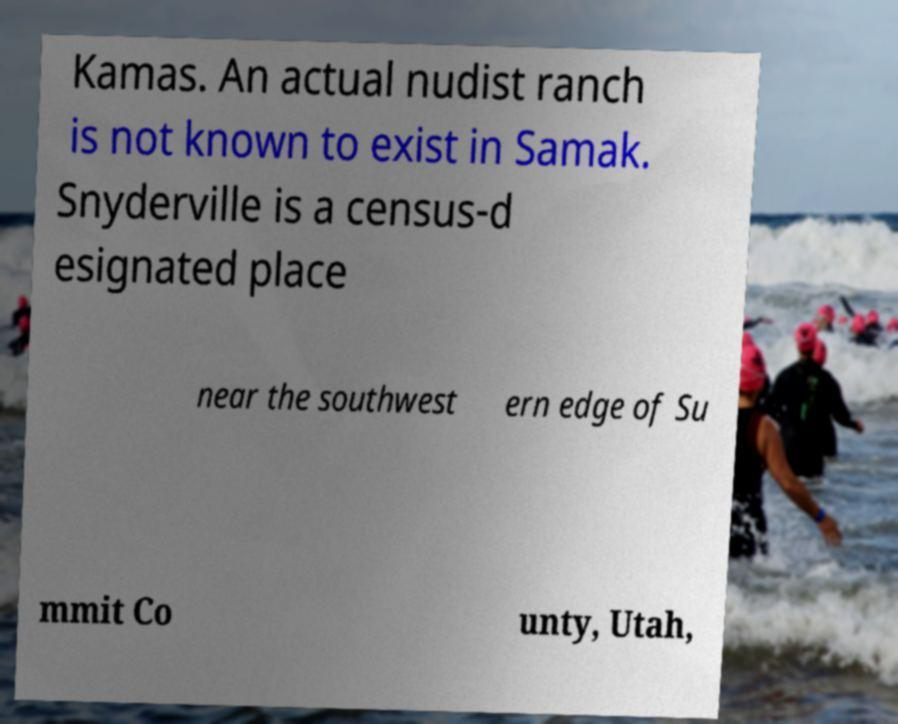There's text embedded in this image that I need extracted. Can you transcribe it verbatim? Kamas. An actual nudist ranch is not known to exist in Samak. Snyderville is a census-d esignated place near the southwest ern edge of Su mmit Co unty, Utah, 